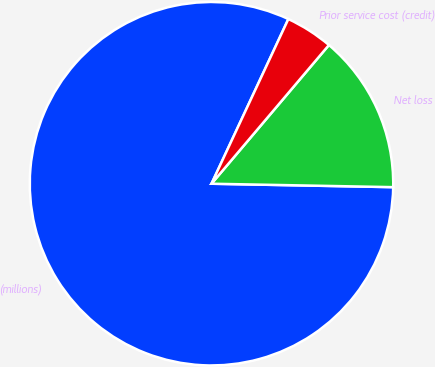Convert chart. <chart><loc_0><loc_0><loc_500><loc_500><pie_chart><fcel>(millions)<fcel>Net loss<fcel>Prior service cost (credit)<nl><fcel>81.65%<fcel>14.12%<fcel>4.23%<nl></chart> 